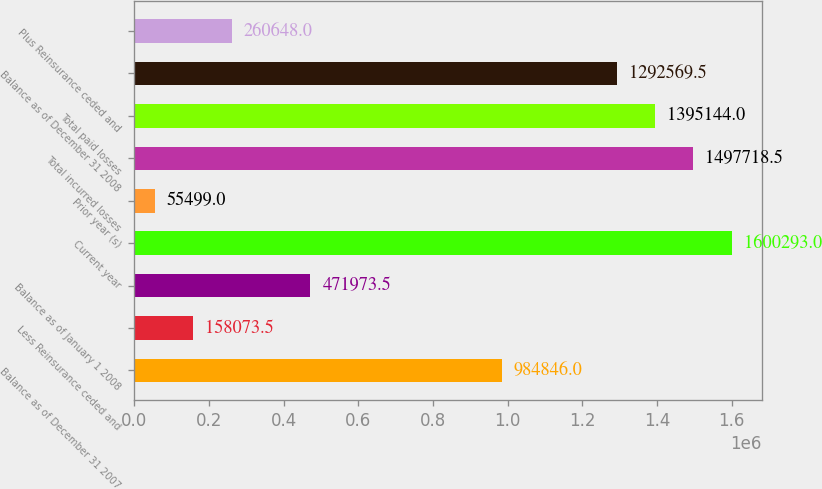<chart> <loc_0><loc_0><loc_500><loc_500><bar_chart><fcel>Balance as of December 31 2007<fcel>Less Reinsurance ceded and<fcel>Balance as of January 1 2008<fcel>Current year<fcel>Prior year (s)<fcel>Total incurred losses<fcel>Total paid losses<fcel>Balance as of December 31 2008<fcel>Plus Reinsurance ceded and<nl><fcel>984846<fcel>158074<fcel>471974<fcel>1.60029e+06<fcel>55499<fcel>1.49772e+06<fcel>1.39514e+06<fcel>1.29257e+06<fcel>260648<nl></chart> 